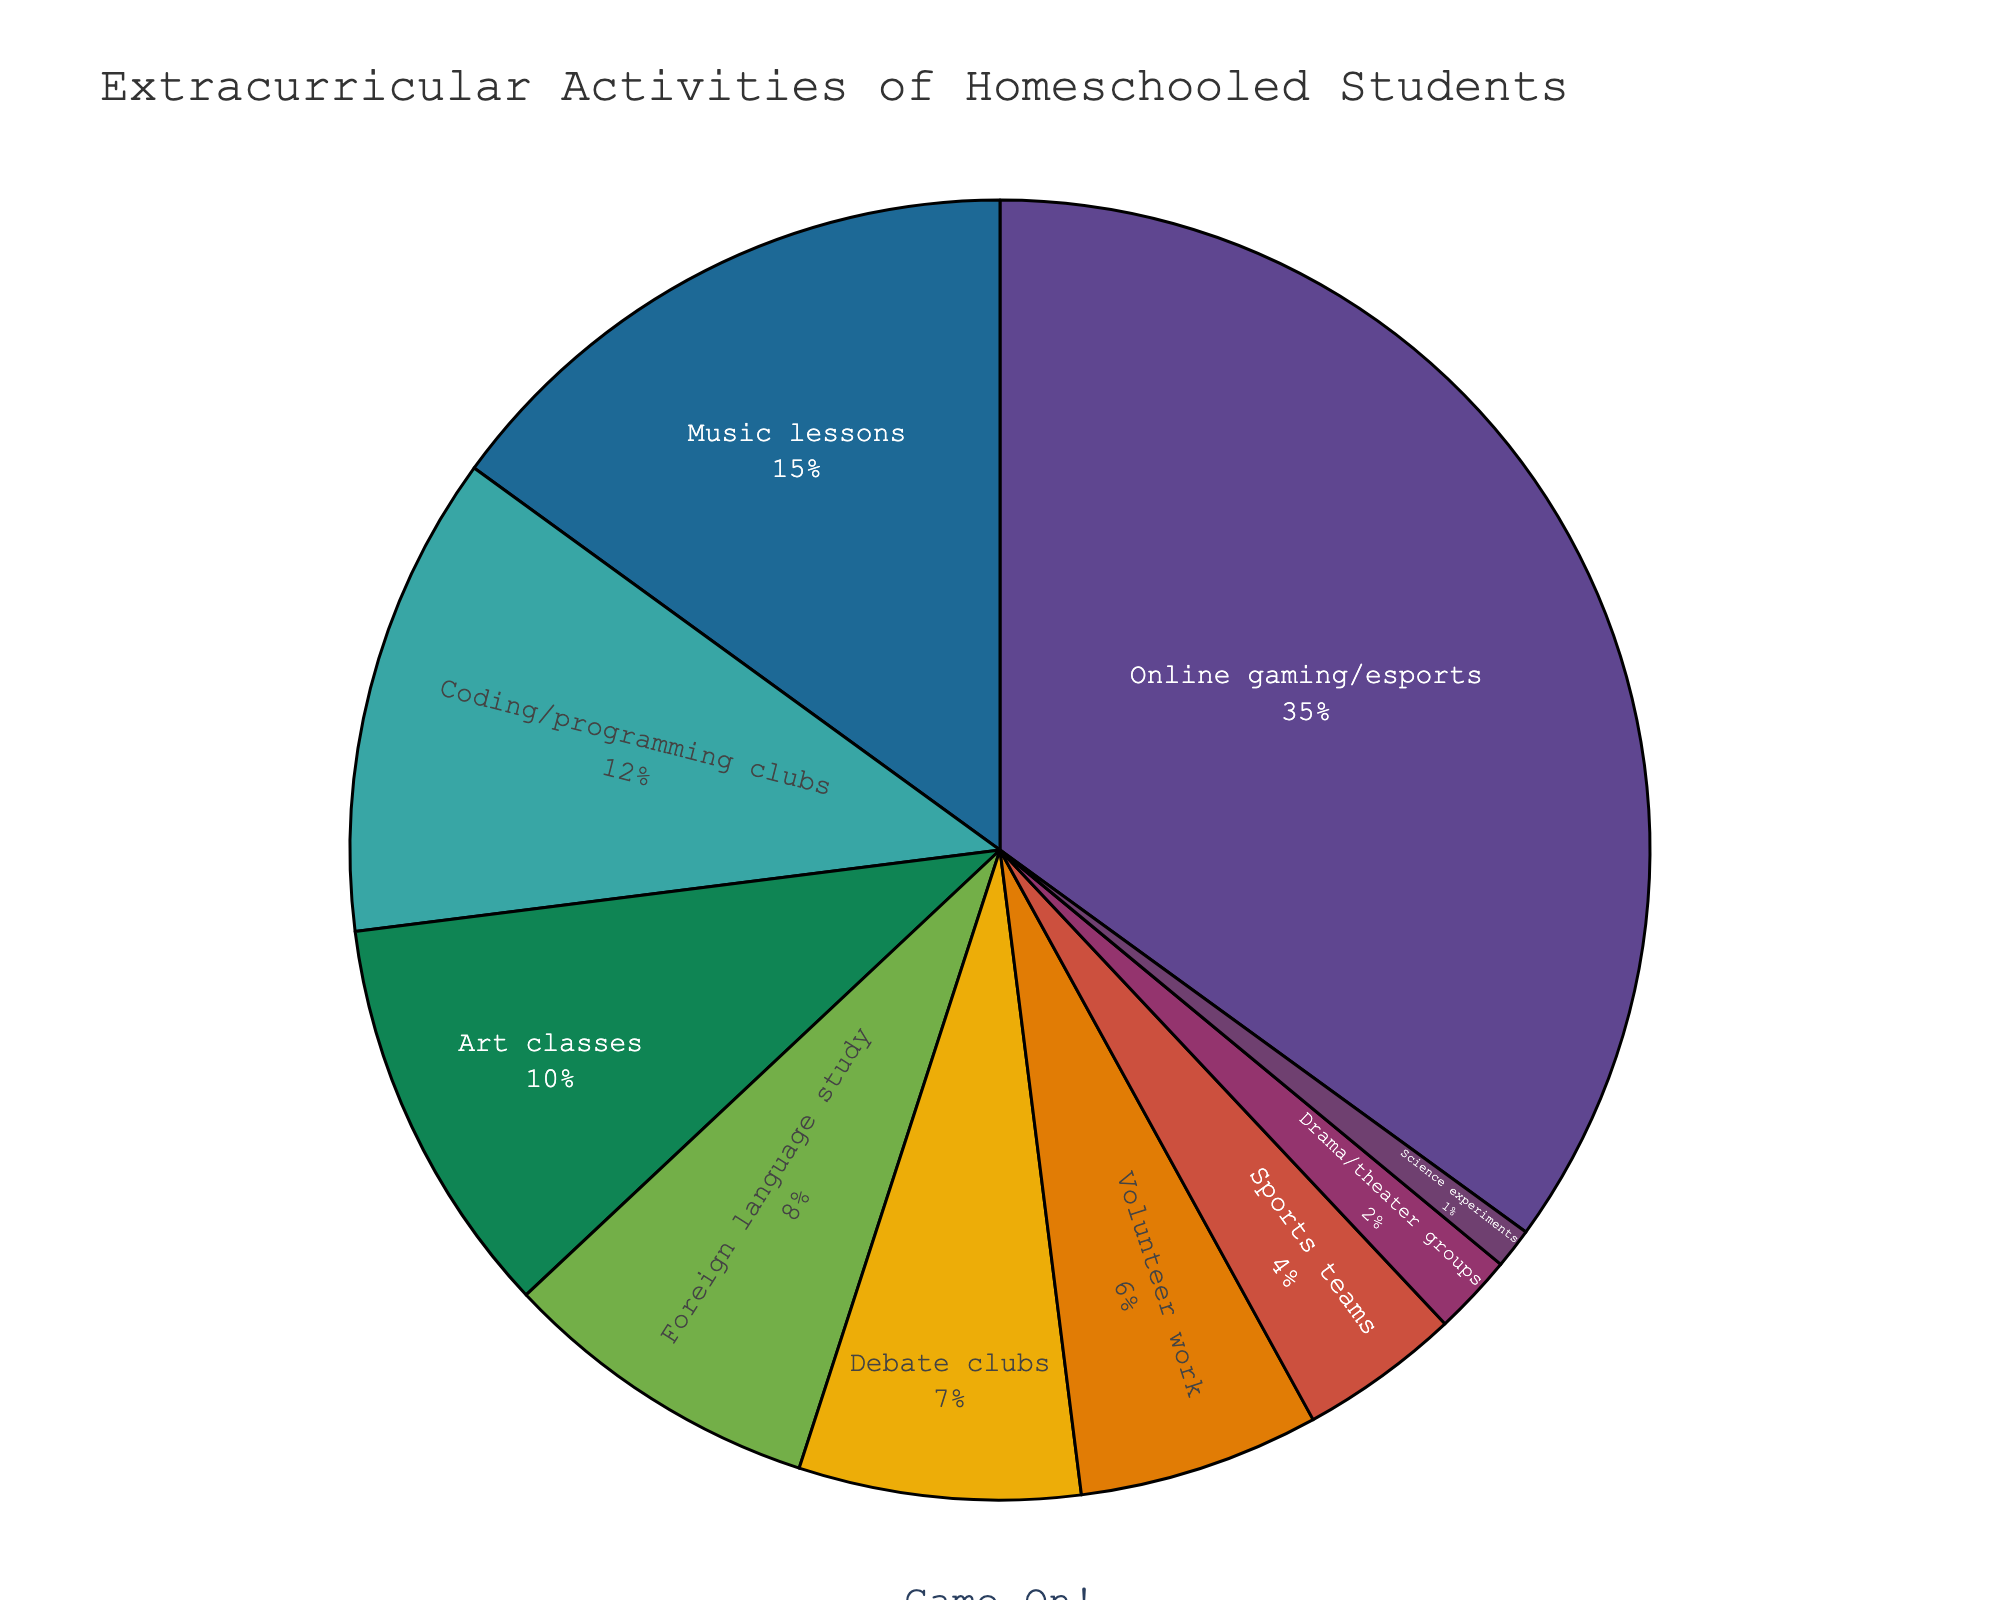What's the most popular extracurricular activity among homeschooled students? The figure shows a pie chart of various extracurricular activities with their respective percentages. The largest slice in the pie chart represents the highest percentage. It can be seen that "Online gaming/esports" has the largest slice, indicating it’s the most popular activity.
Answer: Online gaming/esports How many activities have a percentage higher than 10%? To determine this, we look at the slices in the pie chart with percentages labeled higher than 10%. From the chart, "Online gaming/esports" (35%), "Music lessons" (15%), and "Coding/programming clubs" (12%) are above 10%. Therefore, there are 3 activities.
Answer: 3 What is the combined percentage of students participating in art classes and foreign language study? We sum the percentages for "Art classes" and "Foreign language study". According to the figure, "Art classes" is 10% and "Foreign language study" is 8%. Therefore, 10% + 8% = 18%.
Answer: 18% Which activities have a smaller percentage of participants than sports teams? The pie chart shows that the percentage for "Sports teams" is 4%. Any activity with a smaller percentage than 4% is considered. "Drama/theater groups" (2%) and "Science experiments" (1%) have smaller percentages.
Answer: Drama/theater groups, Science experiments How does the percentage of students in debate clubs compare to those in volunteer work? The pie chart shows the percentages for each activity. The percentage of students in debate clubs is 7%, while those in volunteer work is 6%. Therefore, debate clubs have a 1% higher participation rate than volunteer work.
Answer: Debate clubs have a higher percentage What is the percentage difference between the most and least popular activities? First, identify the most and least popular activities from the pie chart. "Online gaming/esports" is the most popular with 35%, and "Science experiments" is the least popular with 1%. The difference is calculated by subtracting the least from the most: 35% - 1% = 34%.
Answer: 34% Which activities are represented by slices with similar sizes, and what are their respective percentages? By observing the pie chart, we can identify slices that appear roughly the same size. "Coding/programming clubs" (12%) and "Art classes" (10%) have similar-sized slices. Another pair is "Debate clubs" (7%) and "Volunteer work" (6%).
Answer: Coding/programming clubs (12%), Art classes (10%); Debate clubs (7%), Volunteer work (6%) Between music lessons and coding/programming clubs, which has a larger percentage, and by how much? According to the pie chart, music lessons have a percentage of 15% and coding/programming clubs have 12%. Music lessons have a larger percentage. The difference is calculated by subtracting the smaller from the larger: 15% - 12% = 3%.
Answer: Music lessons by 3% 